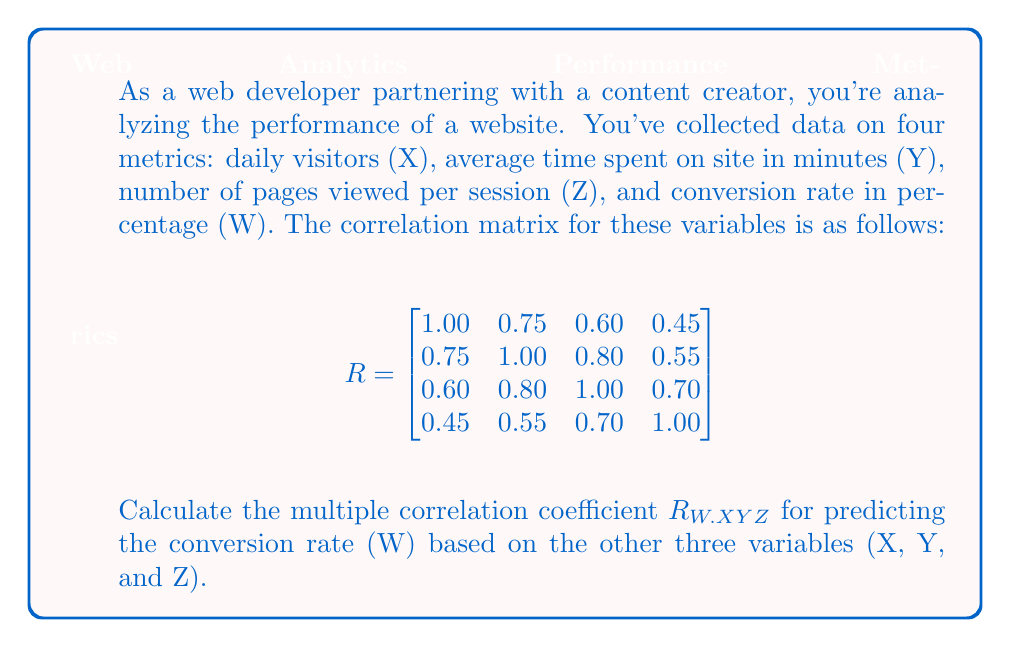What is the answer to this math problem? To calculate the multiple correlation coefficient $R_{W.XYZ}$, we'll follow these steps:

1) The formula for the multiple correlation coefficient is:

   $$R_{W.XYZ} = \sqrt{1 - \frac{1}{R_{WW}}}$$

   where $R_{WW}$ is the determinant of the correlation matrix divided by the minor of $r_{WW}$ (the element in the last row and column).

2) First, we need to calculate the determinant of the full correlation matrix $R$. Let's call this $|R|$:

   $$|R| = 1(1 \cdot 1 \cdot 1 - 1 \cdot 0.80^2 - 0.75^2 \cdot 1 + 2 \cdot 0.75 \cdot 0.60 \cdot 0.80) - 0.75(0.75 \cdot 1 \cdot 1 - 0.60 \cdot 0.80 \cdot 1 - 0.75 \cdot 0.70 \cdot 1 + 0.60 \cdot 0.55 \cdot 1) + 0.60(0.75 \cdot 0.80 \cdot 1 - 0.60 \cdot 1 \cdot 1 - 0.75 \cdot 0.55 \cdot 1 + 0.45 \cdot 1 \cdot 1) - 0.45(0.75 \cdot 0.80 \cdot 0.70 - 0.60 \cdot 1 \cdot 0.70 - 0.75 \cdot 0.55 \cdot 1 + 0.60 \cdot 0.55 \cdot 1)$$

   $$|R| = 0.0934$$

3) Now, we need to calculate the minor of $r_{WW}$, which is the determinant of the 3x3 matrix formed by removing the last row and column:

   $$R_{WW} = \begin{vmatrix}
   1.00 & 0.75 & 0.60 \\
   0.75 & 1.00 & 0.80 \\
   0.60 & 0.80 & 1.00
   \end{vmatrix}$$

   $$R_{WW} = 1 \cdot 1 \cdot 1 - 1 \cdot 0.80^2 - 0.75^2 \cdot 1 + 2 \cdot 0.75 \cdot 0.60 \cdot 0.80 = 0.1975$$

4) Now we can calculate $R_{W.XYZ}$:

   $$R_{W.XYZ} = \sqrt{1 - \frac{|R|}{R_{WW}}} = \sqrt{1 - \frac{0.0934}{0.1975}} = \sqrt{0.5271} = 0.7260$$

Therefore, the multiple correlation coefficient $R_{W.XYZ}$ is approximately 0.7260.
Answer: $R_{W.XYZ} \approx 0.7260$ 